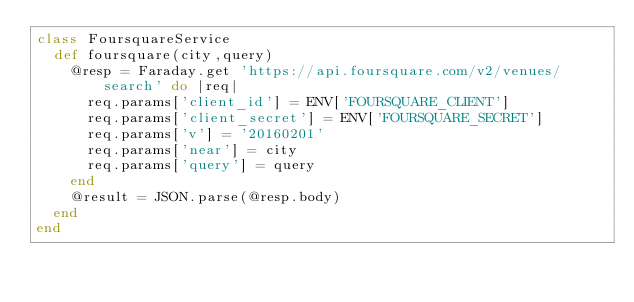<code> <loc_0><loc_0><loc_500><loc_500><_Ruby_>class FoursquareService
  def foursquare(city,query)
    @resp = Faraday.get 'https://api.foursquare.com/v2/venues/search' do |req|
      req.params['client_id'] = ENV['FOURSQUARE_CLIENT']
      req.params['client_secret'] = ENV['FOURSQUARE_SECRET'] 
      req.params['v'] = '20160201'
      req.params['near'] = city
      req.params['query'] = query
    end
    @result = JSON.parse(@resp.body)
  end
end</code> 